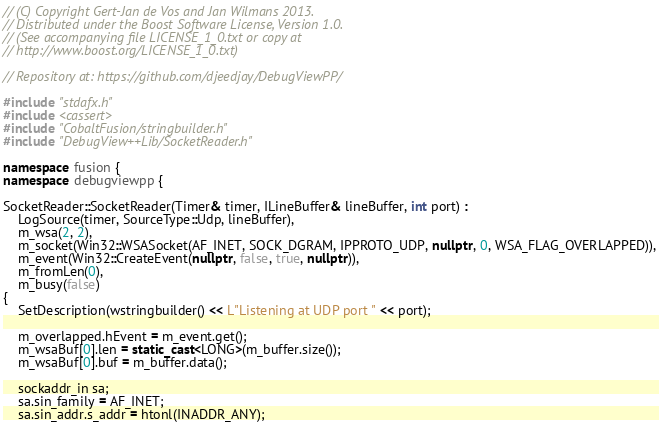<code> <loc_0><loc_0><loc_500><loc_500><_C++_>// (C) Copyright Gert-Jan de Vos and Jan Wilmans 2013.
// Distributed under the Boost Software License, Version 1.0.
// (See accompanying file LICENSE_1_0.txt or copy at
// http://www.boost.org/LICENSE_1_0.txt)

// Repository at: https://github.com/djeedjay/DebugViewPP/

#include "stdafx.h"
#include <cassert>
#include "CobaltFusion/stringbuilder.h"
#include "DebugView++Lib/SocketReader.h"

namespace fusion {
namespace debugviewpp {

SocketReader::SocketReader(Timer& timer, ILineBuffer& lineBuffer, int port) :
    LogSource(timer, SourceType::Udp, lineBuffer),
    m_wsa(2, 2),
    m_socket(Win32::WSASocket(AF_INET, SOCK_DGRAM, IPPROTO_UDP, nullptr, 0, WSA_FLAG_OVERLAPPED)),
    m_event(Win32::CreateEvent(nullptr, false, true, nullptr)),
    m_fromLen(0),
    m_busy(false)
{
    SetDescription(wstringbuilder() << L"Listening at UDP port " << port);

    m_overlapped.hEvent = m_event.get();
    m_wsaBuf[0].len = static_cast<LONG>(m_buffer.size());
    m_wsaBuf[0].buf = m_buffer.data();

    sockaddr_in sa;
    sa.sin_family = AF_INET;
    sa.sin_addr.s_addr = htonl(INADDR_ANY);</code> 